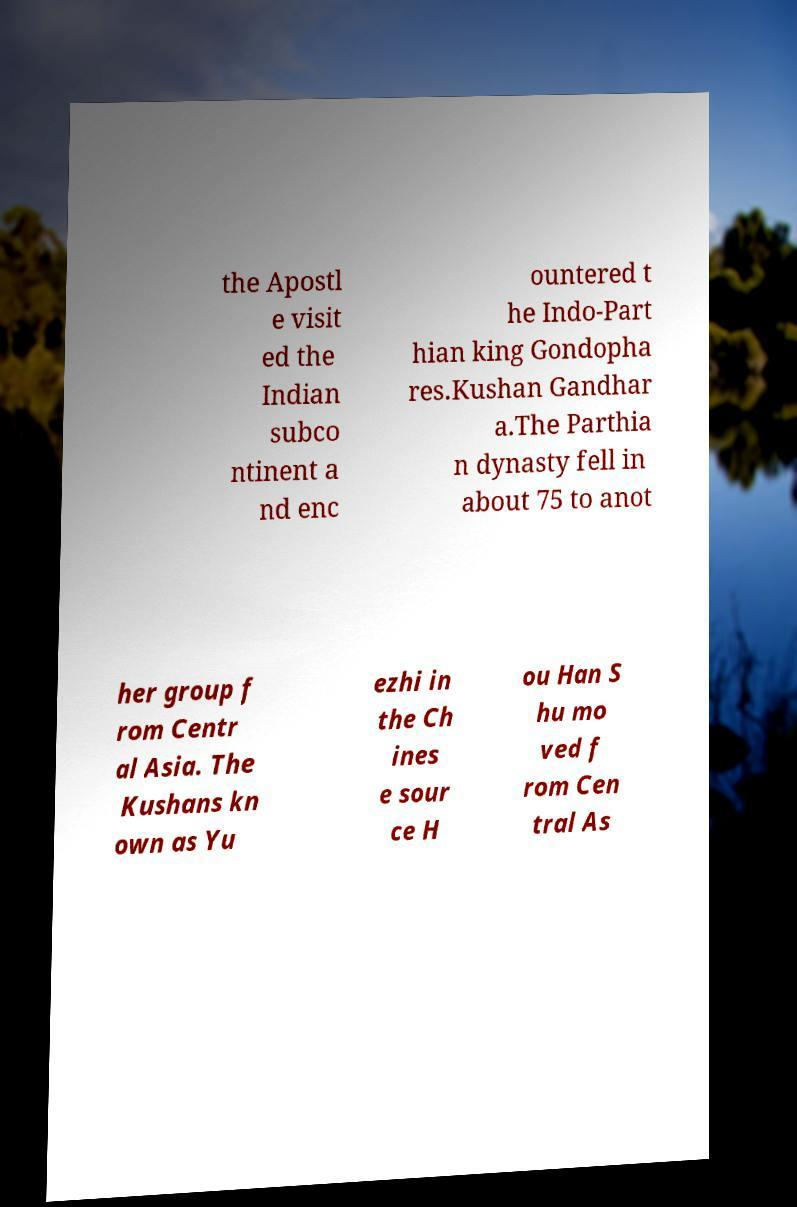Can you accurately transcribe the text from the provided image for me? the Apostl e visit ed the Indian subco ntinent a nd enc ountered t he Indo-Part hian king Gondopha res.Kushan Gandhar a.The Parthia n dynasty fell in about 75 to anot her group f rom Centr al Asia. The Kushans kn own as Yu ezhi in the Ch ines e sour ce H ou Han S hu mo ved f rom Cen tral As 